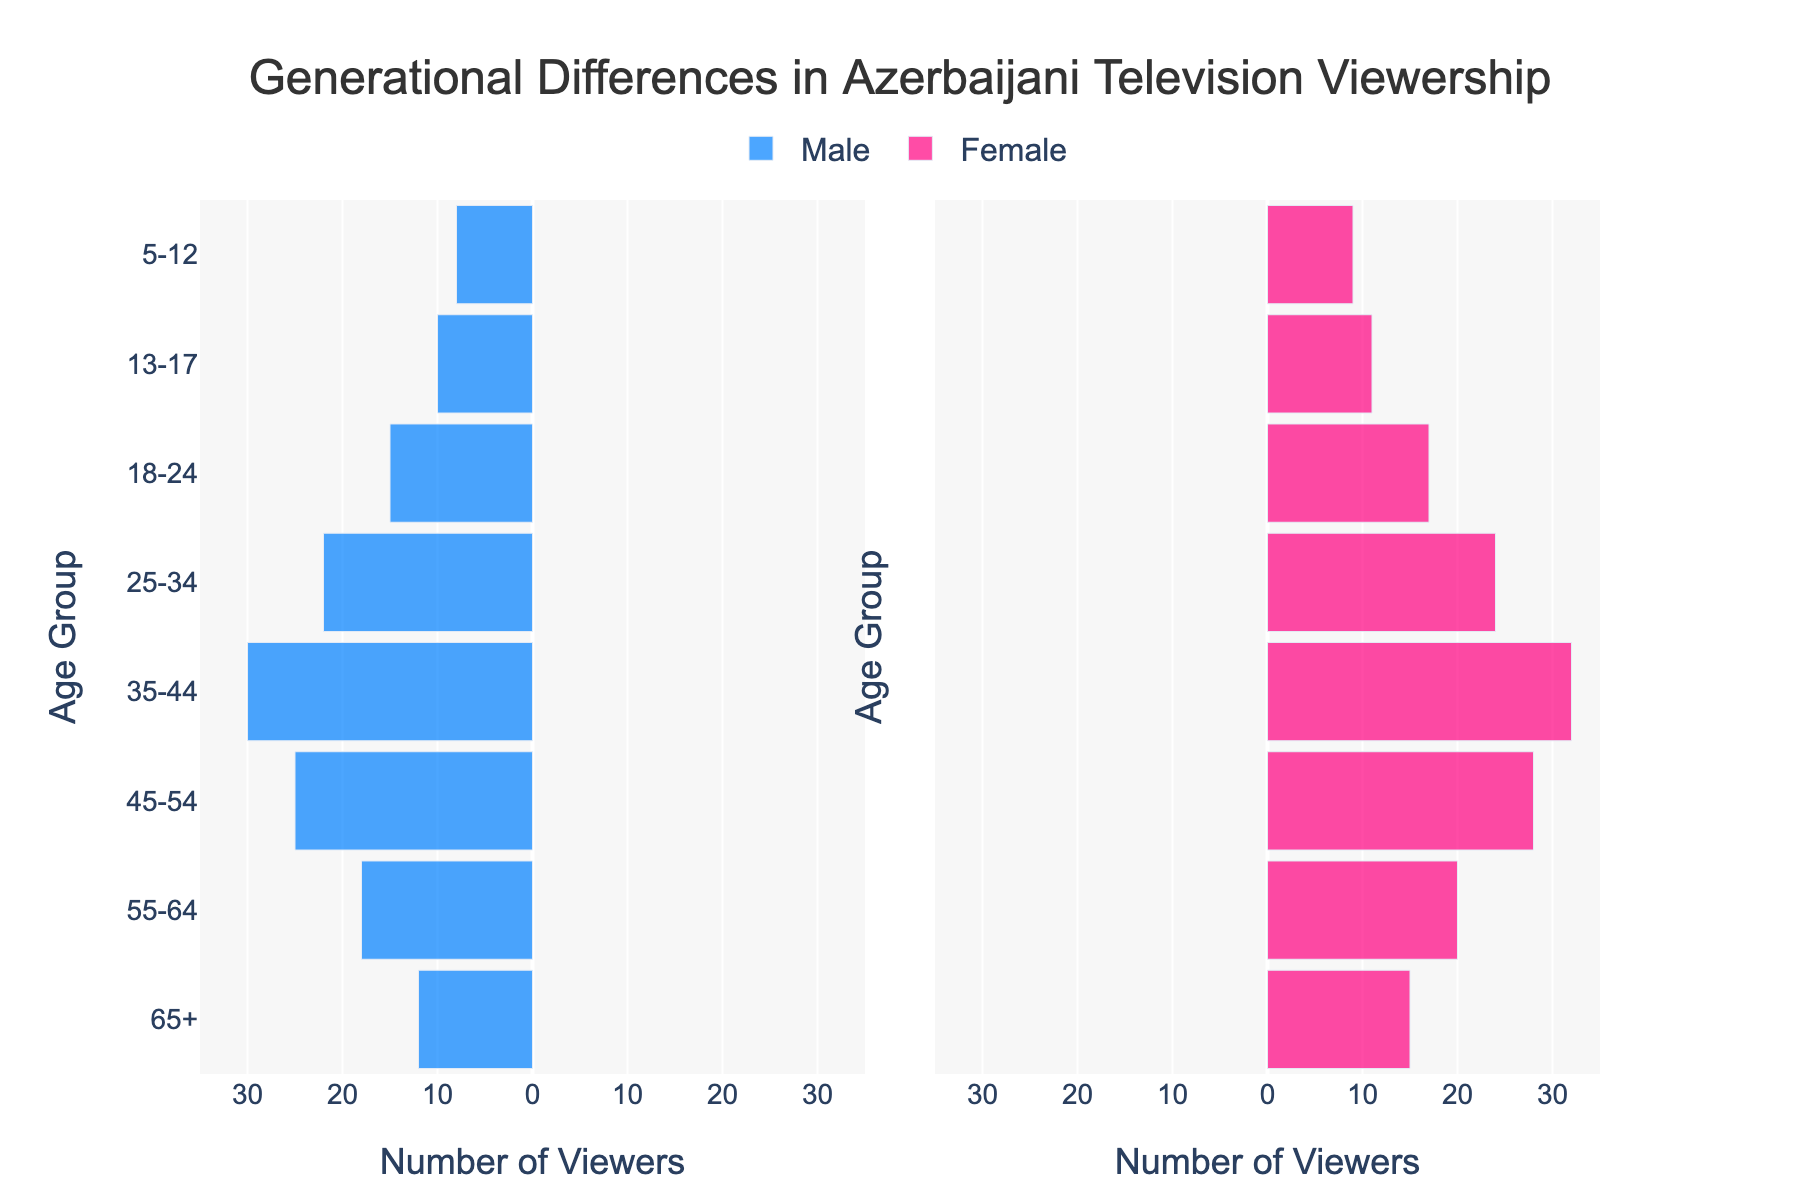What is the overall trend in television viewership among different age groups? The graph shows a pyramid shape indicating that television viewership is generally higher among middle-aged groups (45-54, 35-44) and lower among the youngest (5-12, 13-17) and oldest (65+) age groups.
Answer: Middle-aged viewers watch more TV Which gender has more viewers in the 35-44 age group? From the figure, the bars for male viewers in the 35-44 age group extend to -30, while for female viewers, it goes up to 32. Thus, there are more female viewers.
Answer: Female How many total viewers are there in the 45-54 age group? The number of male viewers is 25 and the number of female viewers is 28. Adding them up gives us 25 + 28 = 53 viewers.
Answer: 53 Which age group has the least number of viewers? The smallest bars for both male and female viewers are present in the 5-12 age group, indicating it has the least viewers.
Answer: 5-12 What is the ratio of male to female viewers in the 18-24 age group? In the 18-24 age group, there are 15 male viewers and 17 female viewers. The ratio of male to female viewers is thus 15/17.
Answer: 15:17 How many more viewers are there in the 55-64 age group compared to the 65+ age group? The 55-64 age group has 18 male viewers and 20 female viewers totaling 38, while the 65+ age group has 12 male viewers and 15 female viewers totaling 27. The difference is 38 - 27 = 11.
Answer: 11 Which gender shows a greater decline in viewership as age increases from 45-54 to 65+? Decline for males: 25 (45-54) to 12 (65+); Decline for females: 28 (45-54) to 15 (65+); The decline is greater for females: 28 - 15 = 13.
Answer: Female In which age group is the difference between male and female viewership the smallest? The differences across age groups are as follows: 5-12 (1), 13-17 (1), 18-24 (2), 25-34 (2), 35-44 (2), 45-54 (3), 55-64 (2), 65+ (3); The smallest differences are found in age groups 5-12 and 13-17 with a difference of 1.
Answer: 5-12 and 13-17 Is television viewership generally balanced between genders across all age groups? The bars for male and female viewers are relatively close to each other across almost all age groups, indicating a fairly balanced viewership between genders.
Answer: Yes 